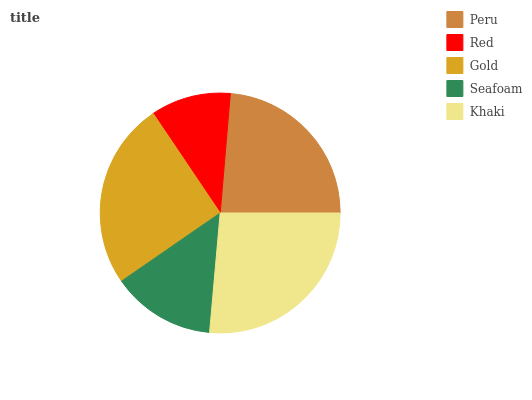Is Red the minimum?
Answer yes or no. Yes. Is Khaki the maximum?
Answer yes or no. Yes. Is Gold the minimum?
Answer yes or no. No. Is Gold the maximum?
Answer yes or no. No. Is Gold greater than Red?
Answer yes or no. Yes. Is Red less than Gold?
Answer yes or no. Yes. Is Red greater than Gold?
Answer yes or no. No. Is Gold less than Red?
Answer yes or no. No. Is Peru the high median?
Answer yes or no. Yes. Is Peru the low median?
Answer yes or no. Yes. Is Red the high median?
Answer yes or no. No. Is Seafoam the low median?
Answer yes or no. No. 